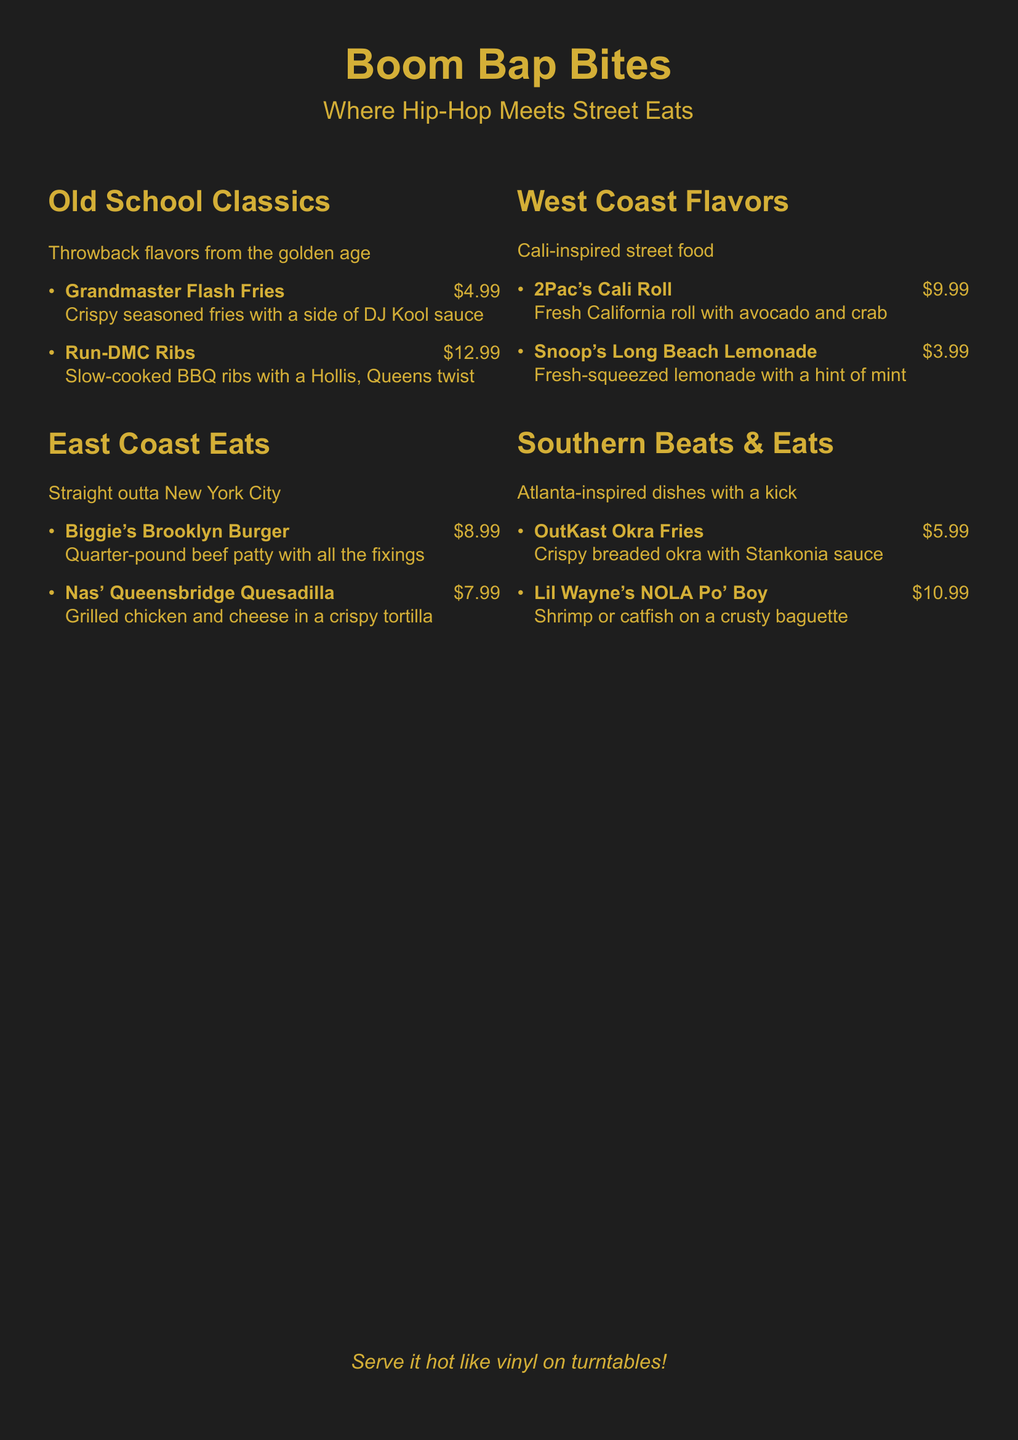What is the name of the restaurant? The name of the restaurant, as stated in the document, is "Boom Bap Bites".
Answer: Boom Bap Bites How much do Biggie's Brooklyn Burger cost? The price for Biggie's Brooklyn Burger is listed in the menu.
Answer: $8.99 What type of drink is Snoop's Long Beach Lemonade? This drink is identified in the menu as a fresh-squeezed lemonade, hinting at its ingredients.
Answer: Fresh-squeezed lemonade How many items are listed under Old School Classics? The menu details the number of items available in the Old School Classics section.
Answer: 2 Which dish is inspired by OutKast? The menu specifies that OutKast is associated with the Okra Fries dish.
Answer: OutKast Okra Fries What type of cuisine is represented in Southern Beats & Eats? The document describes the cuisine in this section as "Atlanta-inspired dishes with a kick".
Answer: Atlanta-inspired How much do Run-DMC Ribs cost? The cost of Run-DMC Ribs is listed in the menu.
Answer: $12.99 What is the main protein in Lil Wayne's NOLA Po' Boy? The menu states the main protein options available in the Po' Boy dish.
Answer: Shrimp or catfish How many sections are there on the menu? The document outlines the various categories of menu items available.
Answer: 4 